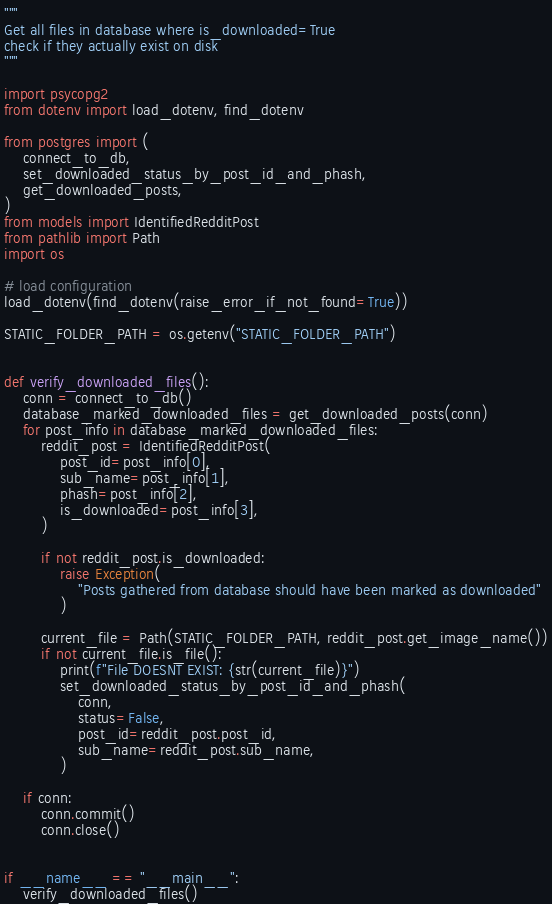Convert code to text. <code><loc_0><loc_0><loc_500><loc_500><_Python_>"""
Get all files in database where is_downloaded=True
check if they actually exist on disk
"""

import psycopg2
from dotenv import load_dotenv, find_dotenv

from postgres import (
    connect_to_db,
    set_downloaded_status_by_post_id_and_phash,
    get_downloaded_posts,
)
from models import IdentifiedRedditPost
from pathlib import Path
import os

# load configuration
load_dotenv(find_dotenv(raise_error_if_not_found=True))

STATIC_FOLDER_PATH = os.getenv("STATIC_FOLDER_PATH")


def verify_downloaded_files():
    conn = connect_to_db()
    database_marked_downloaded_files = get_downloaded_posts(conn)
    for post_info in database_marked_downloaded_files:
        reddit_post = IdentifiedRedditPost(
            post_id=post_info[0],
            sub_name=post_info[1],
            phash=post_info[2],
            is_downloaded=post_info[3],
        )

        if not reddit_post.is_downloaded:
            raise Exception(
                "Posts gathered from database should have been marked as downloaded"
            )

        current_file = Path(STATIC_FOLDER_PATH, reddit_post.get_image_name())
        if not current_file.is_file():
            print(f"File DOESNT EXIST: {str(current_file)}")
            set_downloaded_status_by_post_id_and_phash(
                conn,
                status=False,
                post_id=reddit_post.post_id,
                sub_name=reddit_post.sub_name,
            )

    if conn:
        conn.commit()
        conn.close()


if __name__ == "__main__":
    verify_downloaded_files()
</code> 